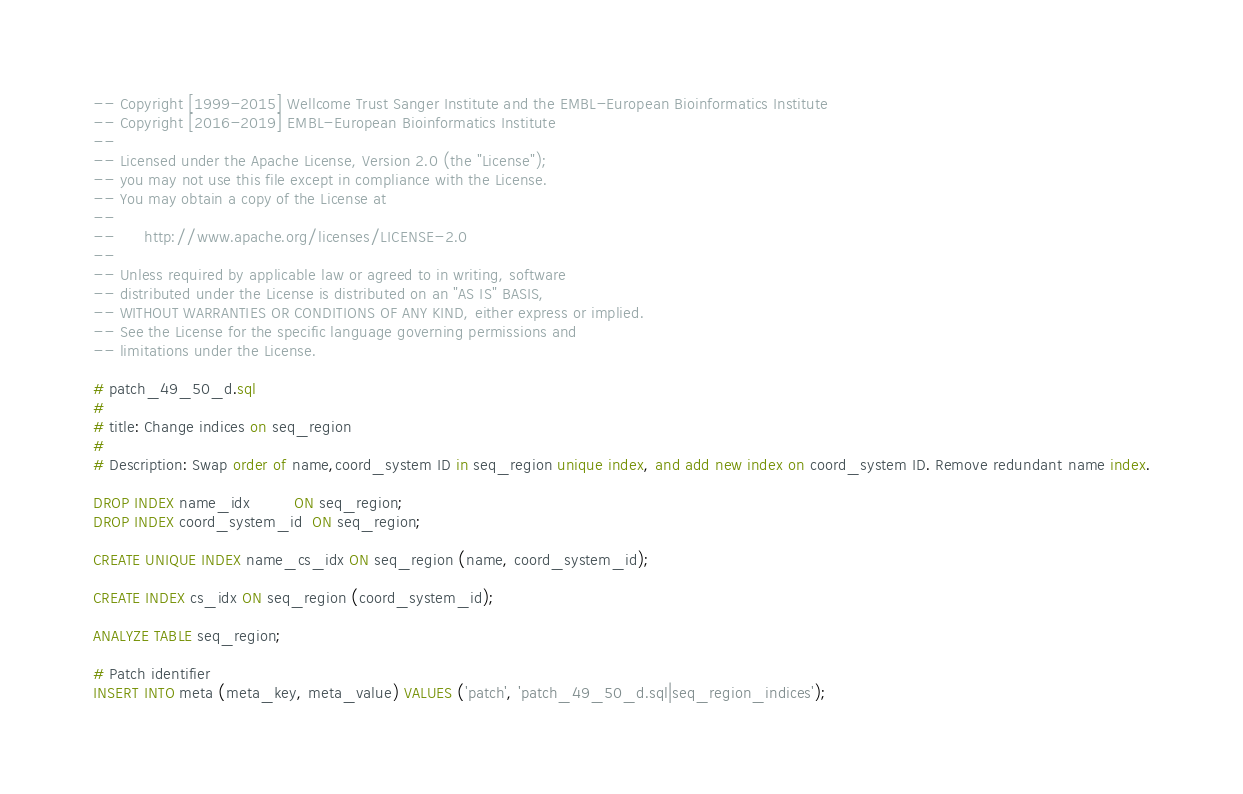Convert code to text. <code><loc_0><loc_0><loc_500><loc_500><_SQL_>-- Copyright [1999-2015] Wellcome Trust Sanger Institute and the EMBL-European Bioinformatics Institute
-- Copyright [2016-2019] EMBL-European Bioinformatics Institute
-- 
-- Licensed under the Apache License, Version 2.0 (the "License");
-- you may not use this file except in compliance with the License.
-- You may obtain a copy of the License at
-- 
--      http://www.apache.org/licenses/LICENSE-2.0
-- 
-- Unless required by applicable law or agreed to in writing, software
-- distributed under the License is distributed on an "AS IS" BASIS,
-- WITHOUT WARRANTIES OR CONDITIONS OF ANY KIND, either express or implied.
-- See the License for the specific language governing permissions and
-- limitations under the License.

# patch_49_50_d.sql
#
# title: Change indices on seq_region
#
# Description: Swap order of name,coord_system ID in seq_region unique index, and add new index on coord_system ID. Remove redundant name index.

DROP INDEX name_idx         ON seq_region;
DROP INDEX coord_system_id  ON seq_region;

CREATE UNIQUE INDEX name_cs_idx ON seq_region (name, coord_system_id);

CREATE INDEX cs_idx ON seq_region (coord_system_id);

ANALYZE TABLE seq_region;

# Patch identifier
INSERT INTO meta (meta_key, meta_value) VALUES ('patch', 'patch_49_50_d.sql|seq_region_indices');



</code> 